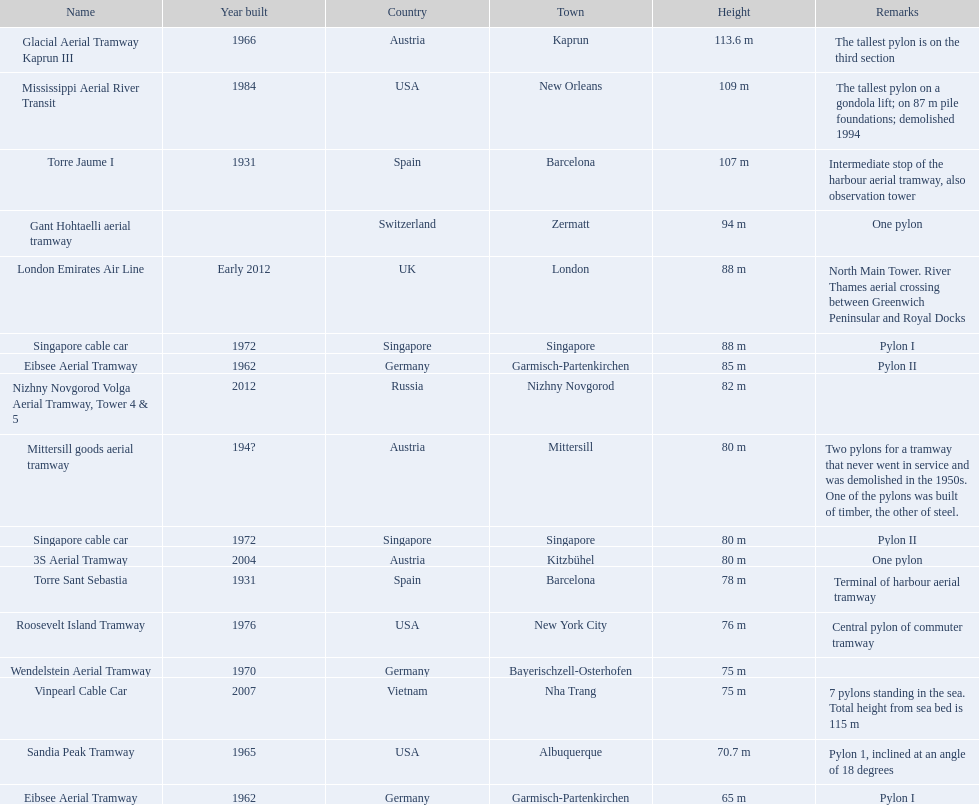Which pylon receives the most comments? Mittersill goods aerial tramway. 